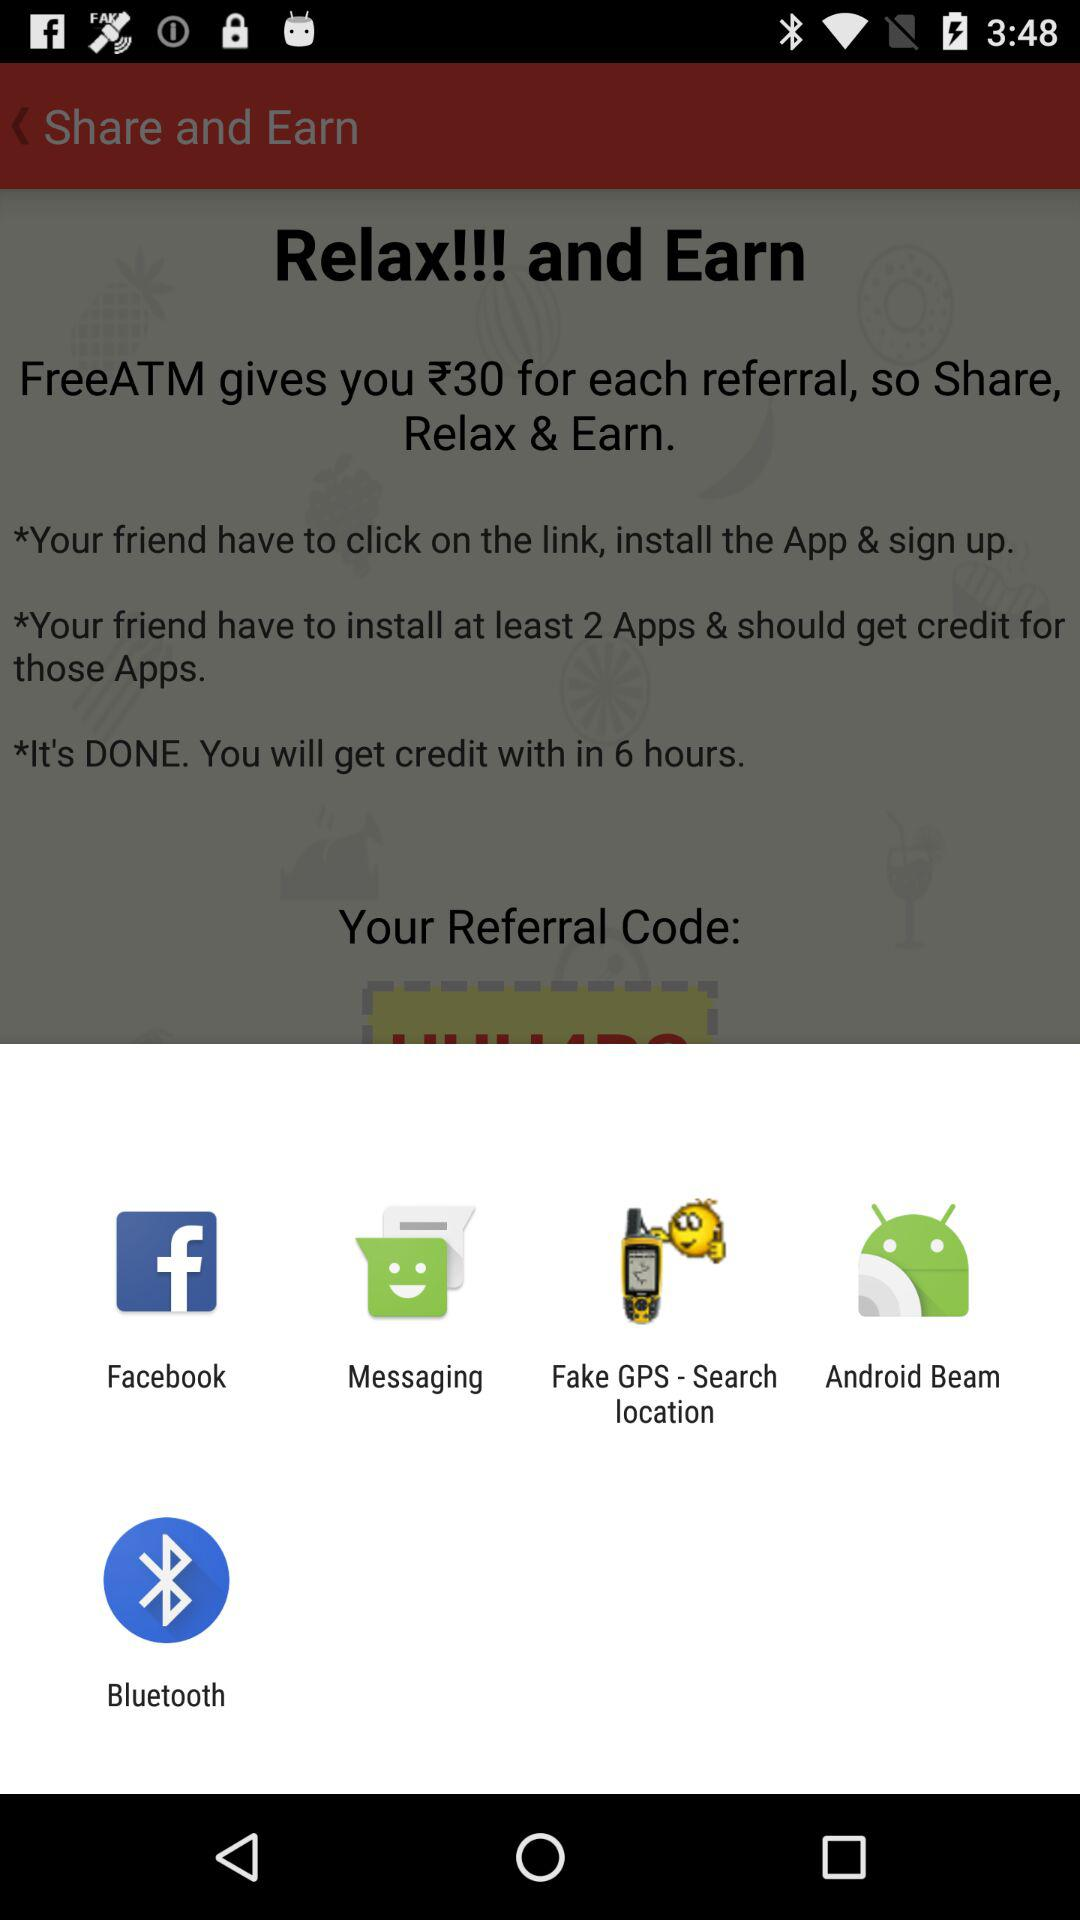How much does "FreeATM" give you for each referral? "FreeATM" gives you ₹30 for each referral. 